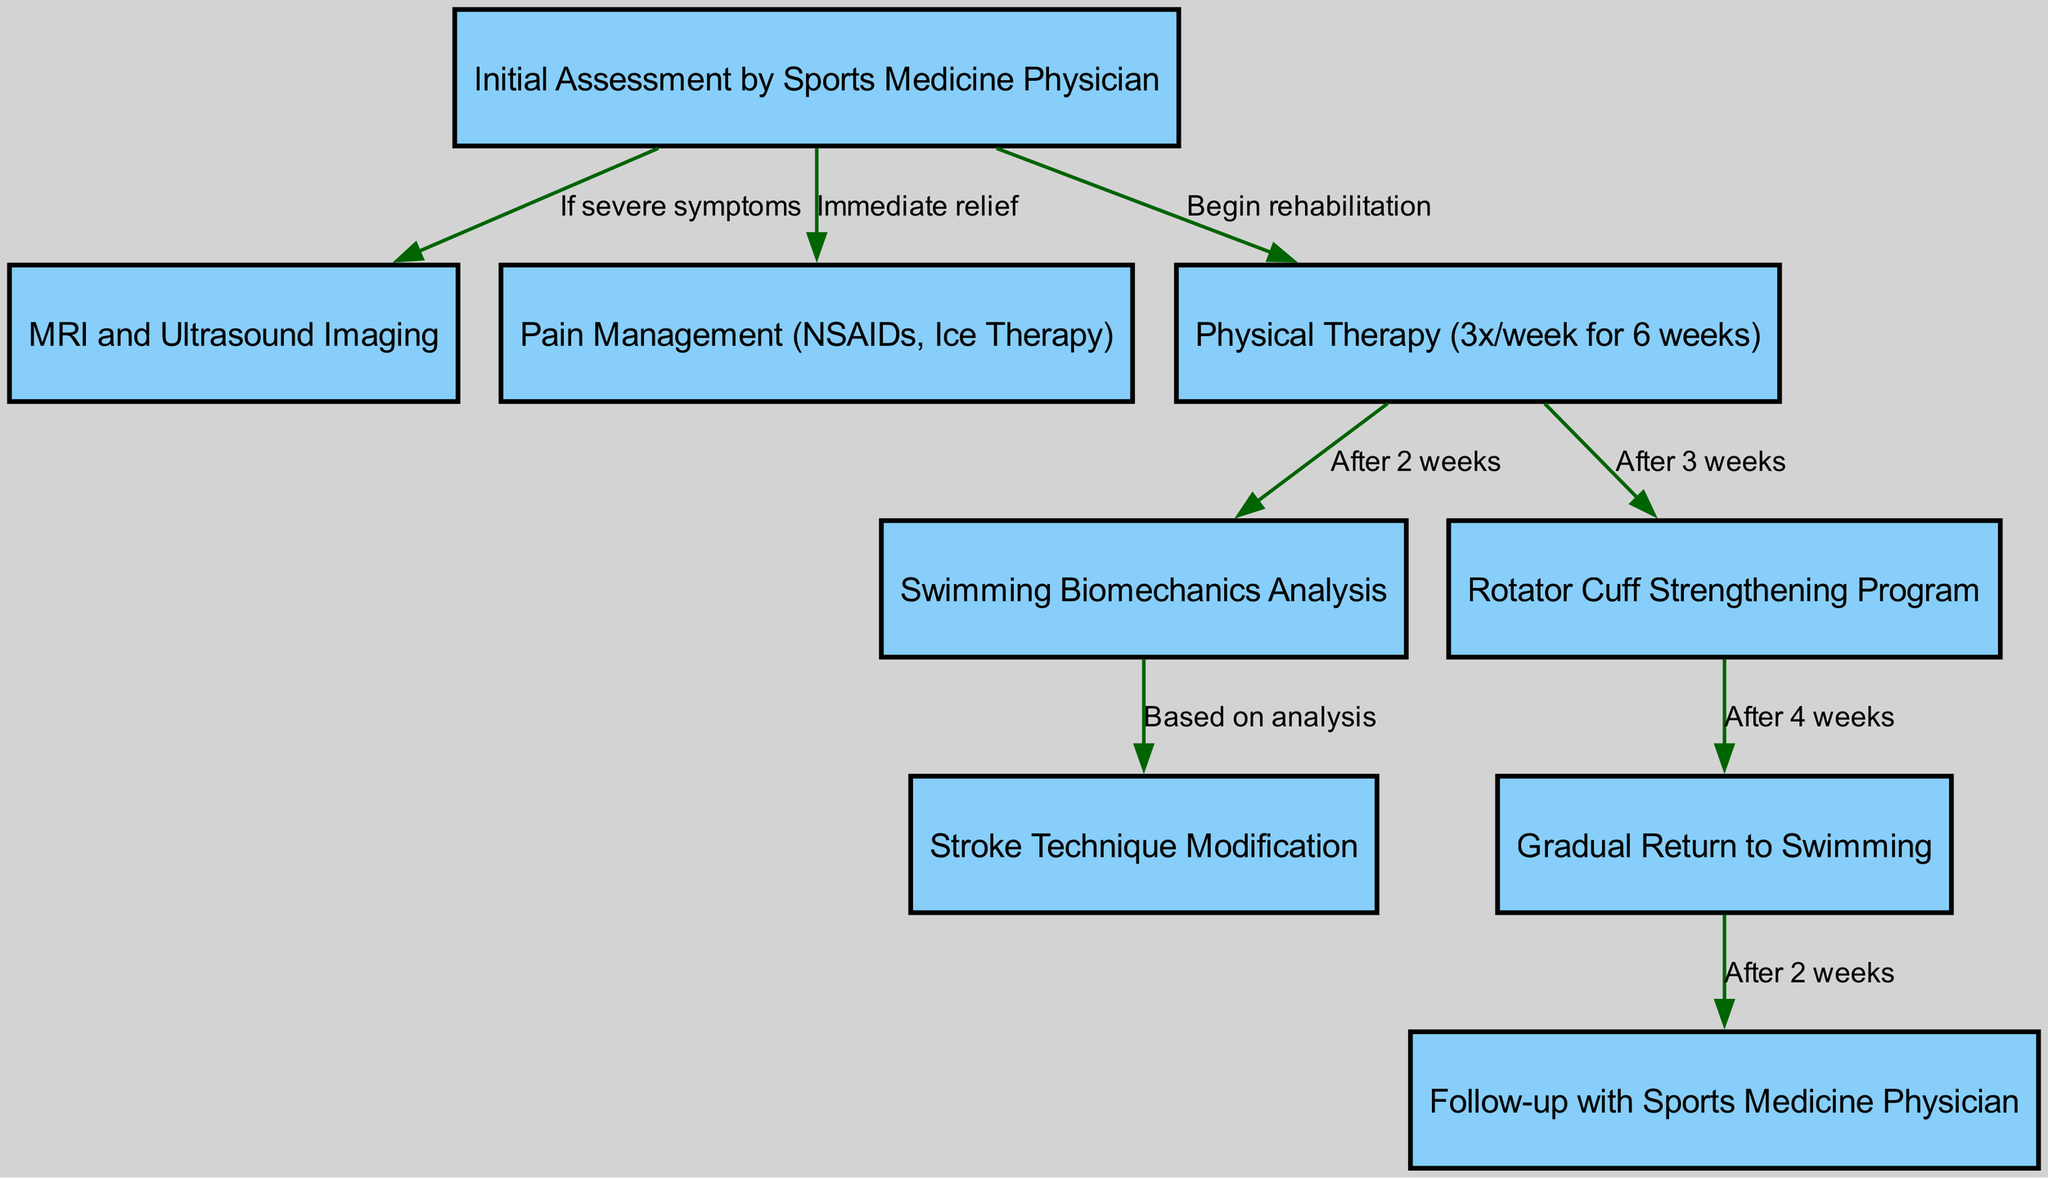What is the first step in the clinical pathway? The diagram indicates that the "Initial Assessment by Sports Medicine Physician" is the first step, as it is the starting node of the pathway.
Answer: Initial Assessment by Sports Medicine Physician How many nodes are present in the diagram? Counting the nodes visually, we observe there are a total of nine distinct elements, each representing a step in the clinical pathway for elite swimmers.
Answer: 9 What does the edge between "initial_assessment" and "pain_management" signify? The edge labeled "Immediate relief" connects these two nodes, indicating that pain management is provided as a response to the initial assessment of symptoms.
Answer: Immediate relief After how many weeks of physical therapy should a biomechanics analysis be conducted? The edge shows that a "Swimming Biomechanics Analysis" should occur "After 2 weeks" of physical therapy, indicating the timing of this analysis in relation to the rehabilitation process.
Answer: After 2 weeks What is the relationship between "strength_training" and "gradual_return"? The diagram illustrates that the "Gradual Return to Swimming" occurs "After 4 weeks" of completing the "Rotator Cuff Strengthening Program," thus indicating a sequential relationship for recovery.
Answer: After 4 weeks Which node follows the "Gradual Return to Swimming"? The diagram shows that a "Follow-up with Sports Medicine Physician" occurs "After 2 weeks" of the gradual return, making it the subsequent step post-recovery.
Answer: Follow-up with Sports Medicine Physician What action is recommended if severe symptoms are reported during the initial assessment? According to the edge connected to the "Initial Assessment," if severe symptoms are present, the next step is to conduct "MRI and Ultrasound Imaging" for further evaluation.
Answer: MRI and Ultrasound Imaging What type of analysis is performed after physical therapy? After 2 weeks of physical therapy, a "Swimming Biomechanics Analysis" is conducted as per the diagram, which provides insight into the swimmer's technique and potential issues.
Answer: Swimming Biomechanics Analysis How many weeks should the swimmer engage in physical therapy? The diagram indicates the recommended frequency of physical therapy is "3x/week for 6 weeks," providing a clear guideline for treatment duration.
Answer: 6 weeks 